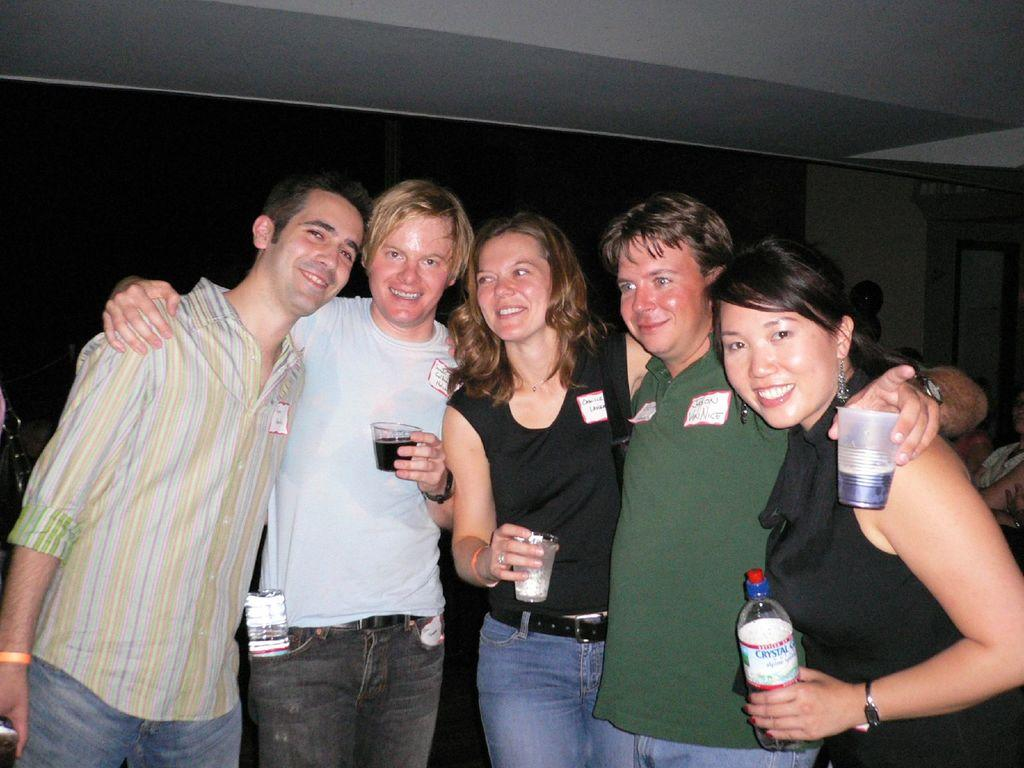What is happening in the image involving a group of people? There is a group of people standing in the foreground, and they are posing for a photo. What are the people holding in their hands? The people are holding glasses in their hands. What type of bone can be seen in the image? There is no bone present in the image; it features a group of people posing for a photo while holding glasses. 